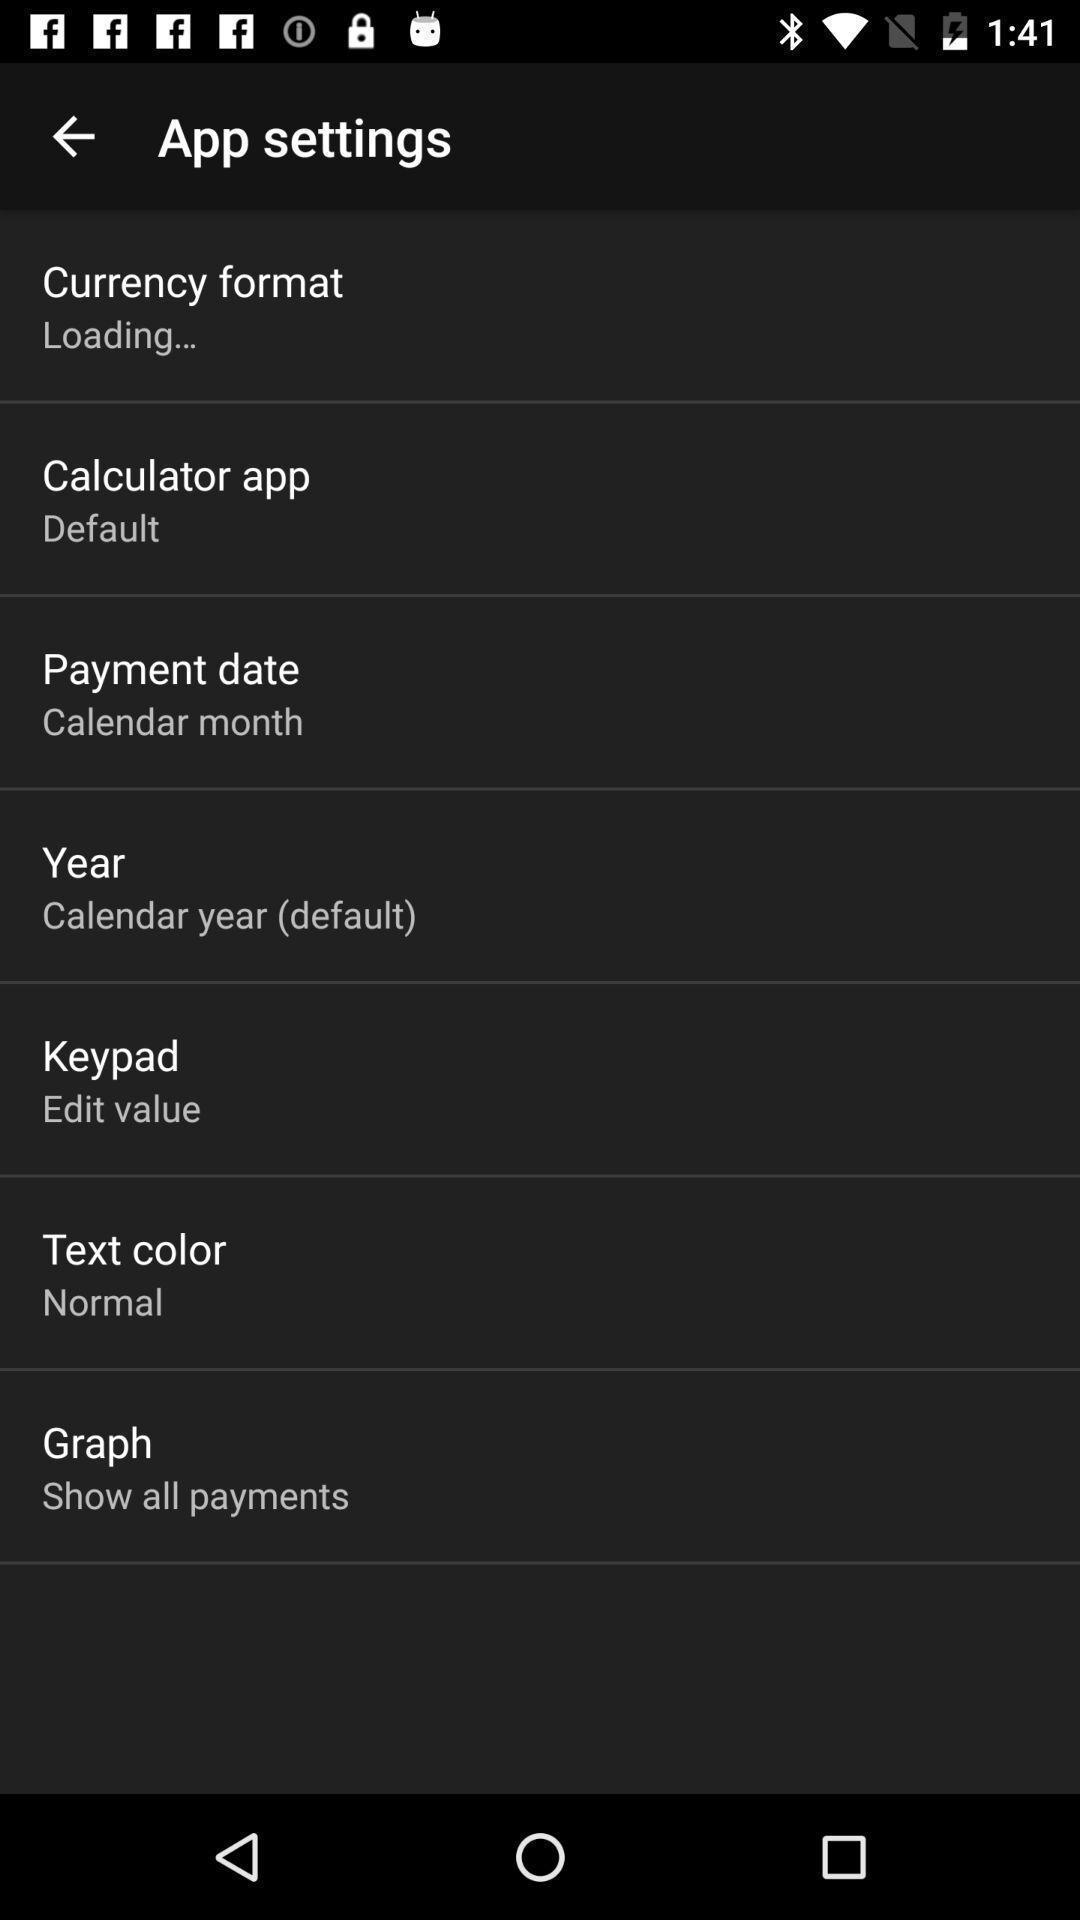Give me a narrative description of this picture. Settings page. 